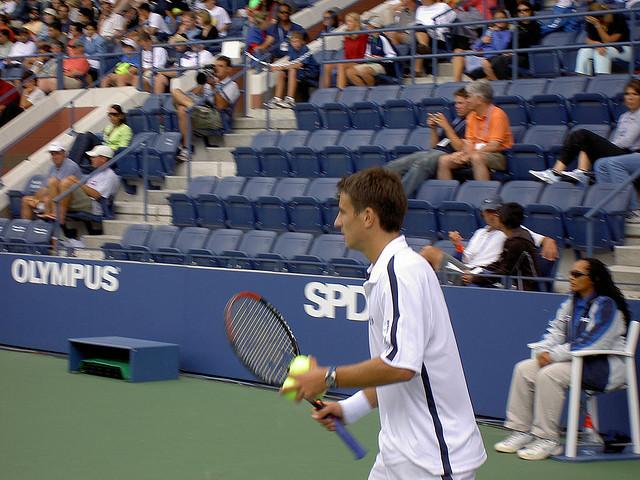Are there two players in the picture?
Answer briefly. No. Is his an indoor tennis tournament?
Write a very short answer. No. What game is being played?
Short answer required. Tennis. 